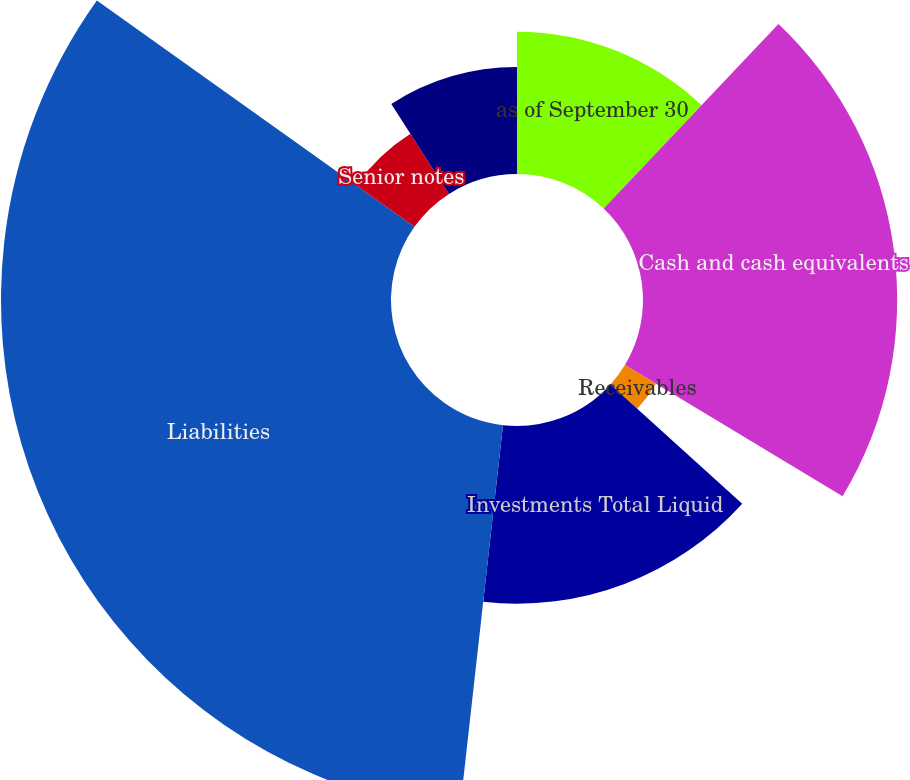Convert chart. <chart><loc_0><loc_0><loc_500><loc_500><pie_chart><fcel>as of September 30<fcel>Cash and cash equivalents<fcel>Receivables<fcel>Investments Total Liquid<fcel>Liabilities<fcel>Senior notes<fcel>Total Debt<nl><fcel>12.07%<fcel>21.56%<fcel>3.07%<fcel>15.07%<fcel>33.08%<fcel>6.07%<fcel>9.07%<nl></chart> 